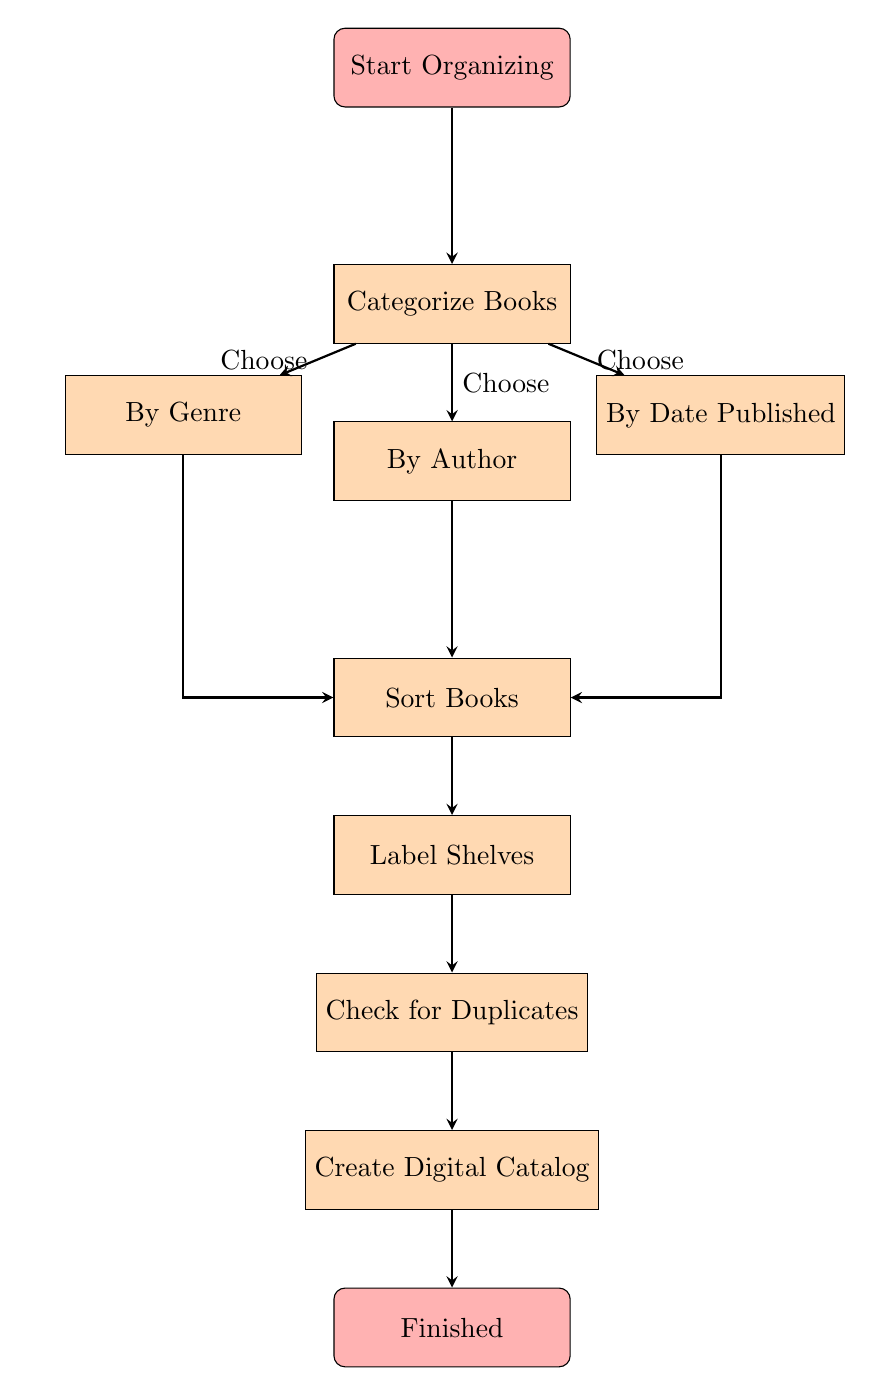What is the first step in the flowchart? The diagram starts with the node labeled "Start Organizing," which indicates the initiation of the process
Answer: Start Organizing How many categorization methods are listed in the diagram? The diagram shows three methods for categorizing books: By Genre, By Author, and By Date Published. Therefore, the total is three methods.
Answer: three Which node comes after the "Categorize Books" node? The flowchart indicates that the next step after "Categorize Books" is "Sort Books," which directly follows the categorization process
Answer: Sort Books What is the last step before finishing the organization? According to the flowchart, "Create Digital Catalog" is the node right before reaching the end of the process, indicating it's the final step needed before finishing
Answer: Create Digital Catalog Which method leads directly to "Sort Books"? In the diagram, the node "By Genre" which is one of the categorization options, leads directly into the "Sort Books" node
Answer: By Genre What is the relationship between "Check for Duplicates" and "Create Digital Catalog"? The flowchart demonstrates that "Check for Duplicates" must be completed before moving on to "Create Digital Catalog," indicating a sequential relationship
Answer: sequential relationship How many nodes are there in total in the diagram? The diagram contains ten nodes, including all the steps from start to finish
Answer: ten After checking for duplicates, which process is initiated? The diagram shows that after checking for duplicates, the next step is to create a digital catalog
Answer: Create Digital Catalog 